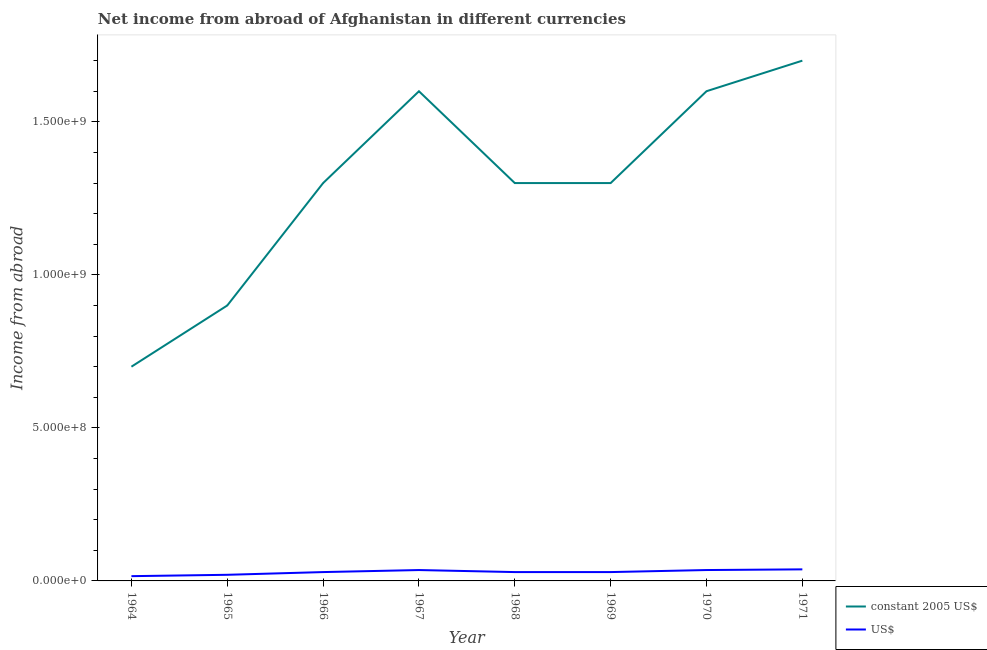How many different coloured lines are there?
Provide a succinct answer. 2. Does the line corresponding to income from abroad in us$ intersect with the line corresponding to income from abroad in constant 2005 us$?
Your response must be concise. No. What is the income from abroad in constant 2005 us$ in 1968?
Ensure brevity in your answer.  1.30e+09. Across all years, what is the maximum income from abroad in us$?
Make the answer very short. 3.78e+07. Across all years, what is the minimum income from abroad in us$?
Your response must be concise. 1.56e+07. In which year was the income from abroad in us$ maximum?
Keep it short and to the point. 1971. In which year was the income from abroad in us$ minimum?
Give a very brief answer. 1964. What is the total income from abroad in us$ in the graph?
Give a very brief answer. 2.31e+08. What is the difference between the income from abroad in us$ in 1965 and that in 1970?
Provide a short and direct response. -1.56e+07. What is the difference between the income from abroad in us$ in 1971 and the income from abroad in constant 2005 us$ in 1965?
Provide a succinct answer. -8.62e+08. What is the average income from abroad in us$ per year?
Keep it short and to the point. 2.89e+07. In the year 1967, what is the difference between the income from abroad in constant 2005 us$ and income from abroad in us$?
Offer a very short reply. 1.56e+09. What is the ratio of the income from abroad in constant 2005 us$ in 1966 to that in 1968?
Provide a short and direct response. 1. Is the income from abroad in constant 2005 us$ in 1966 less than that in 1971?
Offer a terse response. Yes. Is the difference between the income from abroad in us$ in 1964 and 1967 greater than the difference between the income from abroad in constant 2005 us$ in 1964 and 1967?
Offer a terse response. Yes. What is the difference between the highest and the second highest income from abroad in constant 2005 us$?
Make the answer very short. 9.99e+07. What is the difference between the highest and the lowest income from abroad in constant 2005 us$?
Make the answer very short. 1.00e+09. Is the income from abroad in us$ strictly greater than the income from abroad in constant 2005 us$ over the years?
Provide a succinct answer. No. How many years are there in the graph?
Provide a succinct answer. 8. Does the graph contain any zero values?
Provide a succinct answer. No. Where does the legend appear in the graph?
Provide a short and direct response. Bottom right. How are the legend labels stacked?
Provide a short and direct response. Vertical. What is the title of the graph?
Ensure brevity in your answer.  Net income from abroad of Afghanistan in different currencies. Does "Methane" appear as one of the legend labels in the graph?
Your answer should be very brief. No. What is the label or title of the X-axis?
Ensure brevity in your answer.  Year. What is the label or title of the Y-axis?
Offer a very short reply. Income from abroad. What is the Income from abroad of constant 2005 US$ in 1964?
Provide a short and direct response. 7.00e+08. What is the Income from abroad in US$ in 1964?
Keep it short and to the point. 1.56e+07. What is the Income from abroad of constant 2005 US$ in 1965?
Your answer should be very brief. 9.00e+08. What is the Income from abroad in constant 2005 US$ in 1966?
Offer a terse response. 1.30e+09. What is the Income from abroad of US$ in 1966?
Your response must be concise. 2.89e+07. What is the Income from abroad in constant 2005 US$ in 1967?
Offer a terse response. 1.60e+09. What is the Income from abroad in US$ in 1967?
Offer a terse response. 3.56e+07. What is the Income from abroad in constant 2005 US$ in 1968?
Your response must be concise. 1.30e+09. What is the Income from abroad in US$ in 1968?
Your answer should be very brief. 2.89e+07. What is the Income from abroad in constant 2005 US$ in 1969?
Provide a succinct answer. 1.30e+09. What is the Income from abroad of US$ in 1969?
Provide a succinct answer. 2.89e+07. What is the Income from abroad of constant 2005 US$ in 1970?
Your answer should be very brief. 1.60e+09. What is the Income from abroad in US$ in 1970?
Your response must be concise. 3.56e+07. What is the Income from abroad in constant 2005 US$ in 1971?
Provide a succinct answer. 1.70e+09. What is the Income from abroad of US$ in 1971?
Offer a terse response. 3.78e+07. Across all years, what is the maximum Income from abroad in constant 2005 US$?
Your response must be concise. 1.70e+09. Across all years, what is the maximum Income from abroad in US$?
Offer a very short reply. 3.78e+07. Across all years, what is the minimum Income from abroad in constant 2005 US$?
Provide a short and direct response. 7.00e+08. Across all years, what is the minimum Income from abroad in US$?
Give a very brief answer. 1.56e+07. What is the total Income from abroad in constant 2005 US$ in the graph?
Provide a succinct answer. 1.04e+1. What is the total Income from abroad in US$ in the graph?
Offer a very short reply. 2.31e+08. What is the difference between the Income from abroad in constant 2005 US$ in 1964 and that in 1965?
Keep it short and to the point. -2.00e+08. What is the difference between the Income from abroad of US$ in 1964 and that in 1965?
Give a very brief answer. -4.44e+06. What is the difference between the Income from abroad of constant 2005 US$ in 1964 and that in 1966?
Offer a terse response. -6.00e+08. What is the difference between the Income from abroad in US$ in 1964 and that in 1966?
Provide a short and direct response. -1.33e+07. What is the difference between the Income from abroad of constant 2005 US$ in 1964 and that in 1967?
Offer a very short reply. -9.00e+08. What is the difference between the Income from abroad in US$ in 1964 and that in 1967?
Give a very brief answer. -2.00e+07. What is the difference between the Income from abroad of constant 2005 US$ in 1964 and that in 1968?
Your response must be concise. -6.00e+08. What is the difference between the Income from abroad in US$ in 1964 and that in 1968?
Your response must be concise. -1.33e+07. What is the difference between the Income from abroad in constant 2005 US$ in 1964 and that in 1969?
Give a very brief answer. -6.00e+08. What is the difference between the Income from abroad in US$ in 1964 and that in 1969?
Provide a succinct answer. -1.33e+07. What is the difference between the Income from abroad of constant 2005 US$ in 1964 and that in 1970?
Offer a very short reply. -9.00e+08. What is the difference between the Income from abroad of US$ in 1964 and that in 1970?
Make the answer very short. -2.00e+07. What is the difference between the Income from abroad of constant 2005 US$ in 1964 and that in 1971?
Your answer should be compact. -1.00e+09. What is the difference between the Income from abroad in US$ in 1964 and that in 1971?
Make the answer very short. -2.22e+07. What is the difference between the Income from abroad in constant 2005 US$ in 1965 and that in 1966?
Offer a very short reply. -4.00e+08. What is the difference between the Income from abroad of US$ in 1965 and that in 1966?
Your response must be concise. -8.89e+06. What is the difference between the Income from abroad in constant 2005 US$ in 1965 and that in 1967?
Your answer should be compact. -7.00e+08. What is the difference between the Income from abroad of US$ in 1965 and that in 1967?
Provide a short and direct response. -1.56e+07. What is the difference between the Income from abroad of constant 2005 US$ in 1965 and that in 1968?
Your answer should be very brief. -4.00e+08. What is the difference between the Income from abroad of US$ in 1965 and that in 1968?
Give a very brief answer. -8.89e+06. What is the difference between the Income from abroad of constant 2005 US$ in 1965 and that in 1969?
Give a very brief answer. -4.00e+08. What is the difference between the Income from abroad of US$ in 1965 and that in 1969?
Offer a terse response. -8.89e+06. What is the difference between the Income from abroad of constant 2005 US$ in 1965 and that in 1970?
Make the answer very short. -7.00e+08. What is the difference between the Income from abroad in US$ in 1965 and that in 1970?
Keep it short and to the point. -1.56e+07. What is the difference between the Income from abroad of constant 2005 US$ in 1965 and that in 1971?
Ensure brevity in your answer.  -8.00e+08. What is the difference between the Income from abroad in US$ in 1965 and that in 1971?
Offer a terse response. -1.78e+07. What is the difference between the Income from abroad in constant 2005 US$ in 1966 and that in 1967?
Give a very brief answer. -3.00e+08. What is the difference between the Income from abroad of US$ in 1966 and that in 1967?
Your response must be concise. -6.67e+06. What is the difference between the Income from abroad of US$ in 1966 and that in 1968?
Keep it short and to the point. 0. What is the difference between the Income from abroad of constant 2005 US$ in 1966 and that in 1969?
Give a very brief answer. 0. What is the difference between the Income from abroad of US$ in 1966 and that in 1969?
Provide a succinct answer. 0. What is the difference between the Income from abroad of constant 2005 US$ in 1966 and that in 1970?
Your response must be concise. -3.00e+08. What is the difference between the Income from abroad in US$ in 1966 and that in 1970?
Offer a terse response. -6.67e+06. What is the difference between the Income from abroad of constant 2005 US$ in 1966 and that in 1971?
Provide a succinct answer. -4.00e+08. What is the difference between the Income from abroad of US$ in 1966 and that in 1971?
Keep it short and to the point. -8.89e+06. What is the difference between the Income from abroad of constant 2005 US$ in 1967 and that in 1968?
Give a very brief answer. 3.00e+08. What is the difference between the Income from abroad of US$ in 1967 and that in 1968?
Offer a very short reply. 6.67e+06. What is the difference between the Income from abroad in constant 2005 US$ in 1967 and that in 1969?
Offer a terse response. 3.00e+08. What is the difference between the Income from abroad in US$ in 1967 and that in 1969?
Provide a short and direct response. 6.67e+06. What is the difference between the Income from abroad in constant 2005 US$ in 1967 and that in 1970?
Give a very brief answer. -1.00e+05. What is the difference between the Income from abroad of US$ in 1967 and that in 1970?
Your response must be concise. -2221.51. What is the difference between the Income from abroad in constant 2005 US$ in 1967 and that in 1971?
Make the answer very short. -1.00e+08. What is the difference between the Income from abroad of US$ in 1967 and that in 1971?
Your response must be concise. -2.22e+06. What is the difference between the Income from abroad in constant 2005 US$ in 1968 and that in 1970?
Keep it short and to the point. -3.00e+08. What is the difference between the Income from abroad in US$ in 1968 and that in 1970?
Keep it short and to the point. -6.67e+06. What is the difference between the Income from abroad in constant 2005 US$ in 1968 and that in 1971?
Ensure brevity in your answer.  -4.00e+08. What is the difference between the Income from abroad of US$ in 1968 and that in 1971?
Give a very brief answer. -8.89e+06. What is the difference between the Income from abroad of constant 2005 US$ in 1969 and that in 1970?
Your answer should be compact. -3.00e+08. What is the difference between the Income from abroad in US$ in 1969 and that in 1970?
Offer a terse response. -6.67e+06. What is the difference between the Income from abroad in constant 2005 US$ in 1969 and that in 1971?
Give a very brief answer. -4.00e+08. What is the difference between the Income from abroad in US$ in 1969 and that in 1971?
Ensure brevity in your answer.  -8.89e+06. What is the difference between the Income from abroad in constant 2005 US$ in 1970 and that in 1971?
Offer a very short reply. -9.99e+07. What is the difference between the Income from abroad of US$ in 1970 and that in 1971?
Provide a short and direct response. -2.22e+06. What is the difference between the Income from abroad of constant 2005 US$ in 1964 and the Income from abroad of US$ in 1965?
Your answer should be compact. 6.80e+08. What is the difference between the Income from abroad in constant 2005 US$ in 1964 and the Income from abroad in US$ in 1966?
Offer a very short reply. 6.71e+08. What is the difference between the Income from abroad in constant 2005 US$ in 1964 and the Income from abroad in US$ in 1967?
Ensure brevity in your answer.  6.64e+08. What is the difference between the Income from abroad in constant 2005 US$ in 1964 and the Income from abroad in US$ in 1968?
Keep it short and to the point. 6.71e+08. What is the difference between the Income from abroad in constant 2005 US$ in 1964 and the Income from abroad in US$ in 1969?
Your answer should be compact. 6.71e+08. What is the difference between the Income from abroad in constant 2005 US$ in 1964 and the Income from abroad in US$ in 1970?
Give a very brief answer. 6.64e+08. What is the difference between the Income from abroad of constant 2005 US$ in 1964 and the Income from abroad of US$ in 1971?
Provide a succinct answer. 6.62e+08. What is the difference between the Income from abroad of constant 2005 US$ in 1965 and the Income from abroad of US$ in 1966?
Offer a very short reply. 8.71e+08. What is the difference between the Income from abroad in constant 2005 US$ in 1965 and the Income from abroad in US$ in 1967?
Your response must be concise. 8.64e+08. What is the difference between the Income from abroad in constant 2005 US$ in 1965 and the Income from abroad in US$ in 1968?
Give a very brief answer. 8.71e+08. What is the difference between the Income from abroad of constant 2005 US$ in 1965 and the Income from abroad of US$ in 1969?
Your answer should be very brief. 8.71e+08. What is the difference between the Income from abroad of constant 2005 US$ in 1965 and the Income from abroad of US$ in 1970?
Your answer should be compact. 8.64e+08. What is the difference between the Income from abroad of constant 2005 US$ in 1965 and the Income from abroad of US$ in 1971?
Provide a succinct answer. 8.62e+08. What is the difference between the Income from abroad of constant 2005 US$ in 1966 and the Income from abroad of US$ in 1967?
Your answer should be compact. 1.26e+09. What is the difference between the Income from abroad of constant 2005 US$ in 1966 and the Income from abroad of US$ in 1968?
Your answer should be compact. 1.27e+09. What is the difference between the Income from abroad in constant 2005 US$ in 1966 and the Income from abroad in US$ in 1969?
Keep it short and to the point. 1.27e+09. What is the difference between the Income from abroad of constant 2005 US$ in 1966 and the Income from abroad of US$ in 1970?
Keep it short and to the point. 1.26e+09. What is the difference between the Income from abroad in constant 2005 US$ in 1966 and the Income from abroad in US$ in 1971?
Offer a very short reply. 1.26e+09. What is the difference between the Income from abroad in constant 2005 US$ in 1967 and the Income from abroad in US$ in 1968?
Offer a very short reply. 1.57e+09. What is the difference between the Income from abroad in constant 2005 US$ in 1967 and the Income from abroad in US$ in 1969?
Give a very brief answer. 1.57e+09. What is the difference between the Income from abroad in constant 2005 US$ in 1967 and the Income from abroad in US$ in 1970?
Your answer should be compact. 1.56e+09. What is the difference between the Income from abroad in constant 2005 US$ in 1967 and the Income from abroad in US$ in 1971?
Your answer should be compact. 1.56e+09. What is the difference between the Income from abroad in constant 2005 US$ in 1968 and the Income from abroad in US$ in 1969?
Give a very brief answer. 1.27e+09. What is the difference between the Income from abroad of constant 2005 US$ in 1968 and the Income from abroad of US$ in 1970?
Your answer should be compact. 1.26e+09. What is the difference between the Income from abroad of constant 2005 US$ in 1968 and the Income from abroad of US$ in 1971?
Provide a succinct answer. 1.26e+09. What is the difference between the Income from abroad of constant 2005 US$ in 1969 and the Income from abroad of US$ in 1970?
Offer a very short reply. 1.26e+09. What is the difference between the Income from abroad of constant 2005 US$ in 1969 and the Income from abroad of US$ in 1971?
Provide a short and direct response. 1.26e+09. What is the difference between the Income from abroad in constant 2005 US$ in 1970 and the Income from abroad in US$ in 1971?
Your answer should be compact. 1.56e+09. What is the average Income from abroad in constant 2005 US$ per year?
Offer a very short reply. 1.30e+09. What is the average Income from abroad in US$ per year?
Provide a succinct answer. 2.89e+07. In the year 1964, what is the difference between the Income from abroad in constant 2005 US$ and Income from abroad in US$?
Give a very brief answer. 6.84e+08. In the year 1965, what is the difference between the Income from abroad in constant 2005 US$ and Income from abroad in US$?
Keep it short and to the point. 8.80e+08. In the year 1966, what is the difference between the Income from abroad in constant 2005 US$ and Income from abroad in US$?
Your answer should be compact. 1.27e+09. In the year 1967, what is the difference between the Income from abroad of constant 2005 US$ and Income from abroad of US$?
Offer a terse response. 1.56e+09. In the year 1968, what is the difference between the Income from abroad in constant 2005 US$ and Income from abroad in US$?
Offer a very short reply. 1.27e+09. In the year 1969, what is the difference between the Income from abroad in constant 2005 US$ and Income from abroad in US$?
Provide a succinct answer. 1.27e+09. In the year 1970, what is the difference between the Income from abroad in constant 2005 US$ and Income from abroad in US$?
Keep it short and to the point. 1.56e+09. In the year 1971, what is the difference between the Income from abroad in constant 2005 US$ and Income from abroad in US$?
Your answer should be very brief. 1.66e+09. What is the ratio of the Income from abroad of constant 2005 US$ in 1964 to that in 1965?
Keep it short and to the point. 0.78. What is the ratio of the Income from abroad of US$ in 1964 to that in 1965?
Make the answer very short. 0.78. What is the ratio of the Income from abroad in constant 2005 US$ in 1964 to that in 1966?
Provide a succinct answer. 0.54. What is the ratio of the Income from abroad of US$ in 1964 to that in 1966?
Make the answer very short. 0.54. What is the ratio of the Income from abroad in constant 2005 US$ in 1964 to that in 1967?
Offer a terse response. 0.44. What is the ratio of the Income from abroad in US$ in 1964 to that in 1967?
Offer a terse response. 0.44. What is the ratio of the Income from abroad in constant 2005 US$ in 1964 to that in 1968?
Your answer should be very brief. 0.54. What is the ratio of the Income from abroad of US$ in 1964 to that in 1968?
Ensure brevity in your answer.  0.54. What is the ratio of the Income from abroad in constant 2005 US$ in 1964 to that in 1969?
Your answer should be very brief. 0.54. What is the ratio of the Income from abroad of US$ in 1964 to that in 1969?
Offer a terse response. 0.54. What is the ratio of the Income from abroad in constant 2005 US$ in 1964 to that in 1970?
Offer a terse response. 0.44. What is the ratio of the Income from abroad of US$ in 1964 to that in 1970?
Ensure brevity in your answer.  0.44. What is the ratio of the Income from abroad of constant 2005 US$ in 1964 to that in 1971?
Provide a short and direct response. 0.41. What is the ratio of the Income from abroad of US$ in 1964 to that in 1971?
Provide a short and direct response. 0.41. What is the ratio of the Income from abroad in constant 2005 US$ in 1965 to that in 1966?
Offer a very short reply. 0.69. What is the ratio of the Income from abroad in US$ in 1965 to that in 1966?
Provide a short and direct response. 0.69. What is the ratio of the Income from abroad of constant 2005 US$ in 1965 to that in 1967?
Offer a very short reply. 0.56. What is the ratio of the Income from abroad in US$ in 1965 to that in 1967?
Offer a very short reply. 0.56. What is the ratio of the Income from abroad in constant 2005 US$ in 1965 to that in 1968?
Provide a short and direct response. 0.69. What is the ratio of the Income from abroad of US$ in 1965 to that in 1968?
Your answer should be very brief. 0.69. What is the ratio of the Income from abroad of constant 2005 US$ in 1965 to that in 1969?
Give a very brief answer. 0.69. What is the ratio of the Income from abroad in US$ in 1965 to that in 1969?
Your answer should be compact. 0.69. What is the ratio of the Income from abroad in constant 2005 US$ in 1965 to that in 1970?
Provide a short and direct response. 0.56. What is the ratio of the Income from abroad of US$ in 1965 to that in 1970?
Offer a terse response. 0.56. What is the ratio of the Income from abroad in constant 2005 US$ in 1965 to that in 1971?
Ensure brevity in your answer.  0.53. What is the ratio of the Income from abroad in US$ in 1965 to that in 1971?
Offer a terse response. 0.53. What is the ratio of the Income from abroad of constant 2005 US$ in 1966 to that in 1967?
Your response must be concise. 0.81. What is the ratio of the Income from abroad of US$ in 1966 to that in 1967?
Your response must be concise. 0.81. What is the ratio of the Income from abroad of constant 2005 US$ in 1966 to that in 1968?
Your response must be concise. 1. What is the ratio of the Income from abroad in US$ in 1966 to that in 1968?
Provide a succinct answer. 1. What is the ratio of the Income from abroad in constant 2005 US$ in 1966 to that in 1969?
Offer a very short reply. 1. What is the ratio of the Income from abroad of constant 2005 US$ in 1966 to that in 1970?
Your answer should be very brief. 0.81. What is the ratio of the Income from abroad in US$ in 1966 to that in 1970?
Make the answer very short. 0.81. What is the ratio of the Income from abroad of constant 2005 US$ in 1966 to that in 1971?
Offer a terse response. 0.76. What is the ratio of the Income from abroad in US$ in 1966 to that in 1971?
Your response must be concise. 0.76. What is the ratio of the Income from abroad in constant 2005 US$ in 1967 to that in 1968?
Your response must be concise. 1.23. What is the ratio of the Income from abroad in US$ in 1967 to that in 1968?
Provide a succinct answer. 1.23. What is the ratio of the Income from abroad of constant 2005 US$ in 1967 to that in 1969?
Make the answer very short. 1.23. What is the ratio of the Income from abroad of US$ in 1967 to that in 1969?
Give a very brief answer. 1.23. What is the ratio of the Income from abroad in US$ in 1967 to that in 1970?
Make the answer very short. 1. What is the ratio of the Income from abroad in US$ in 1967 to that in 1971?
Ensure brevity in your answer.  0.94. What is the ratio of the Income from abroad of constant 2005 US$ in 1968 to that in 1969?
Make the answer very short. 1. What is the ratio of the Income from abroad of US$ in 1968 to that in 1969?
Ensure brevity in your answer.  1. What is the ratio of the Income from abroad of constant 2005 US$ in 1968 to that in 1970?
Your answer should be compact. 0.81. What is the ratio of the Income from abroad of US$ in 1968 to that in 1970?
Your response must be concise. 0.81. What is the ratio of the Income from abroad of constant 2005 US$ in 1968 to that in 1971?
Offer a terse response. 0.76. What is the ratio of the Income from abroad of US$ in 1968 to that in 1971?
Provide a succinct answer. 0.76. What is the ratio of the Income from abroad in constant 2005 US$ in 1969 to that in 1970?
Your answer should be very brief. 0.81. What is the ratio of the Income from abroad in US$ in 1969 to that in 1970?
Your answer should be compact. 0.81. What is the ratio of the Income from abroad in constant 2005 US$ in 1969 to that in 1971?
Make the answer very short. 0.76. What is the ratio of the Income from abroad of US$ in 1969 to that in 1971?
Your answer should be very brief. 0.76. What is the ratio of the Income from abroad in constant 2005 US$ in 1970 to that in 1971?
Your answer should be very brief. 0.94. What is the difference between the highest and the second highest Income from abroad of constant 2005 US$?
Give a very brief answer. 9.99e+07. What is the difference between the highest and the second highest Income from abroad of US$?
Your response must be concise. 2.22e+06. What is the difference between the highest and the lowest Income from abroad in constant 2005 US$?
Ensure brevity in your answer.  1.00e+09. What is the difference between the highest and the lowest Income from abroad of US$?
Keep it short and to the point. 2.22e+07. 